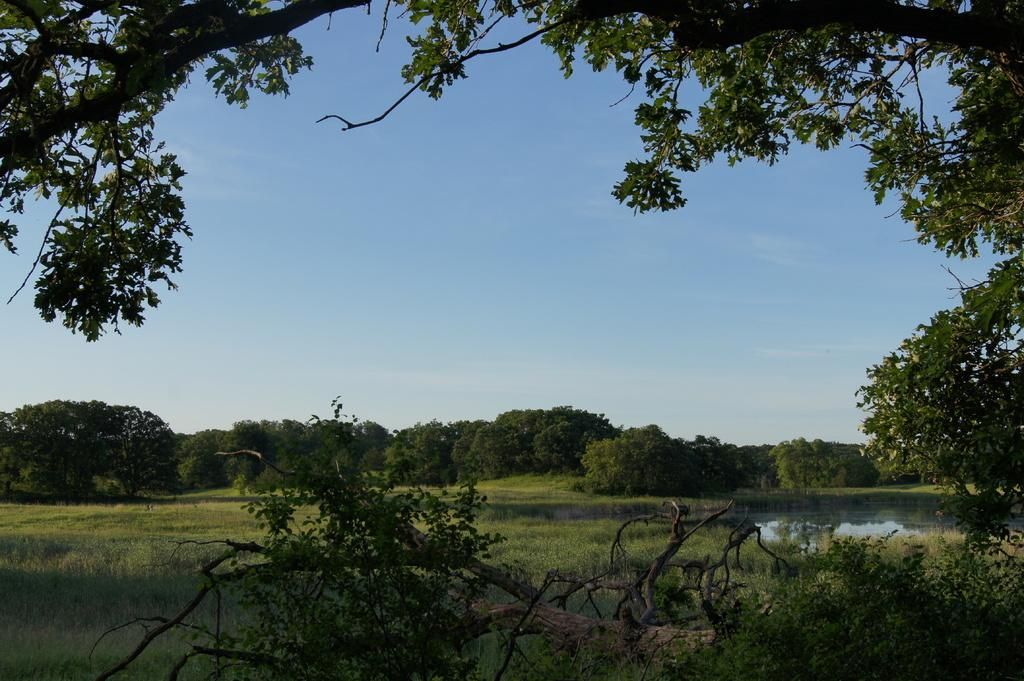What type of vegetation can be seen in the image in the image? There is a group of trees and grass in the image. What else can be found in the image besides the trees and grass? There is water in the image. What is visible in the background of the image? The sky is visible in the background of the image. What type of pickle is being served to the group of trees in the image? There is no pickle or serving of any kind present in the image; it features a group of trees, grass, water, and the sky. 